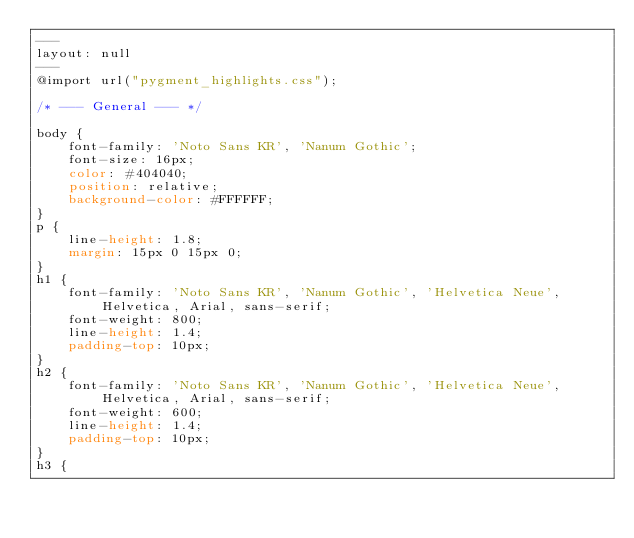Convert code to text. <code><loc_0><loc_0><loc_500><loc_500><_CSS_>---
layout: null
---
@import url("pygment_highlights.css");

/* --- General --- */

body {
    font-family: 'Noto Sans KR', 'Nanum Gothic';
    font-size: 16px;
    color: #404040;
    position: relative;
    background-color: #FFFFFF;
}
p {
    line-height: 1.8;
    margin: 15px 0 15px 0;
}
h1 {
    font-family: 'Noto Sans KR', 'Nanum Gothic', 'Helvetica Neue', Helvetica, Arial, sans-serif;
    font-weight: 800;
    line-height: 1.4;
    padding-top: 10px;
}
h2 {
    font-family: 'Noto Sans KR', 'Nanum Gothic', 'Helvetica Neue', Helvetica, Arial, sans-serif;
    font-weight: 600;
    line-height: 1.4;
    padding-top: 10px;
}
h3 {</code> 